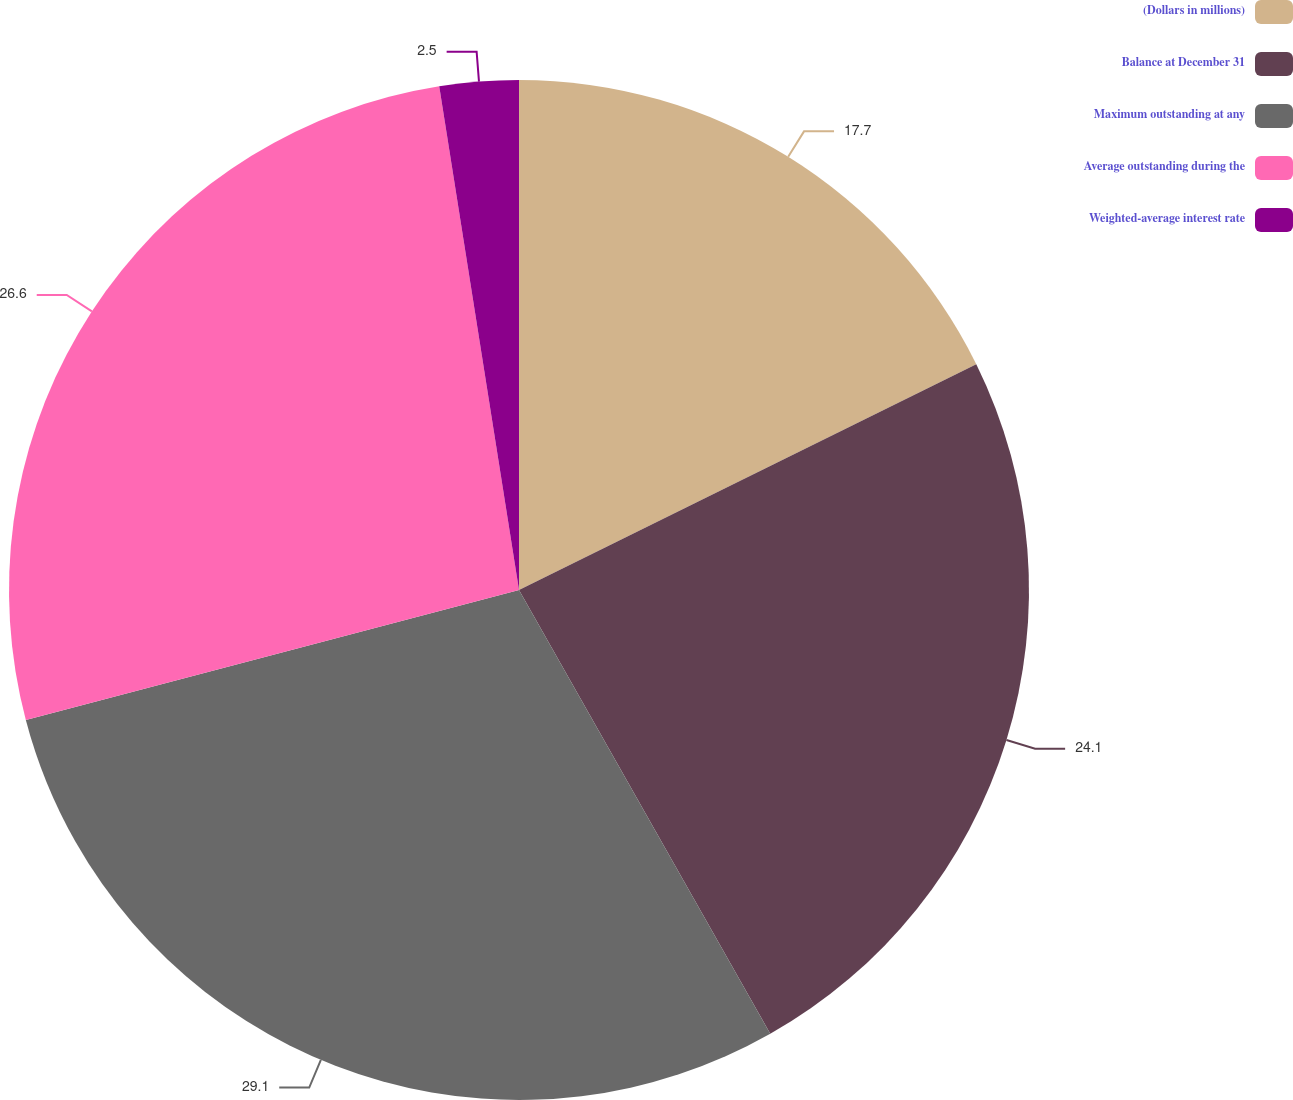<chart> <loc_0><loc_0><loc_500><loc_500><pie_chart><fcel>(Dollars in millions)<fcel>Balance at December 31<fcel>Maximum outstanding at any<fcel>Average outstanding during the<fcel>Weighted-average interest rate<nl><fcel>17.7%<fcel>24.1%<fcel>29.1%<fcel>26.6%<fcel>2.5%<nl></chart> 